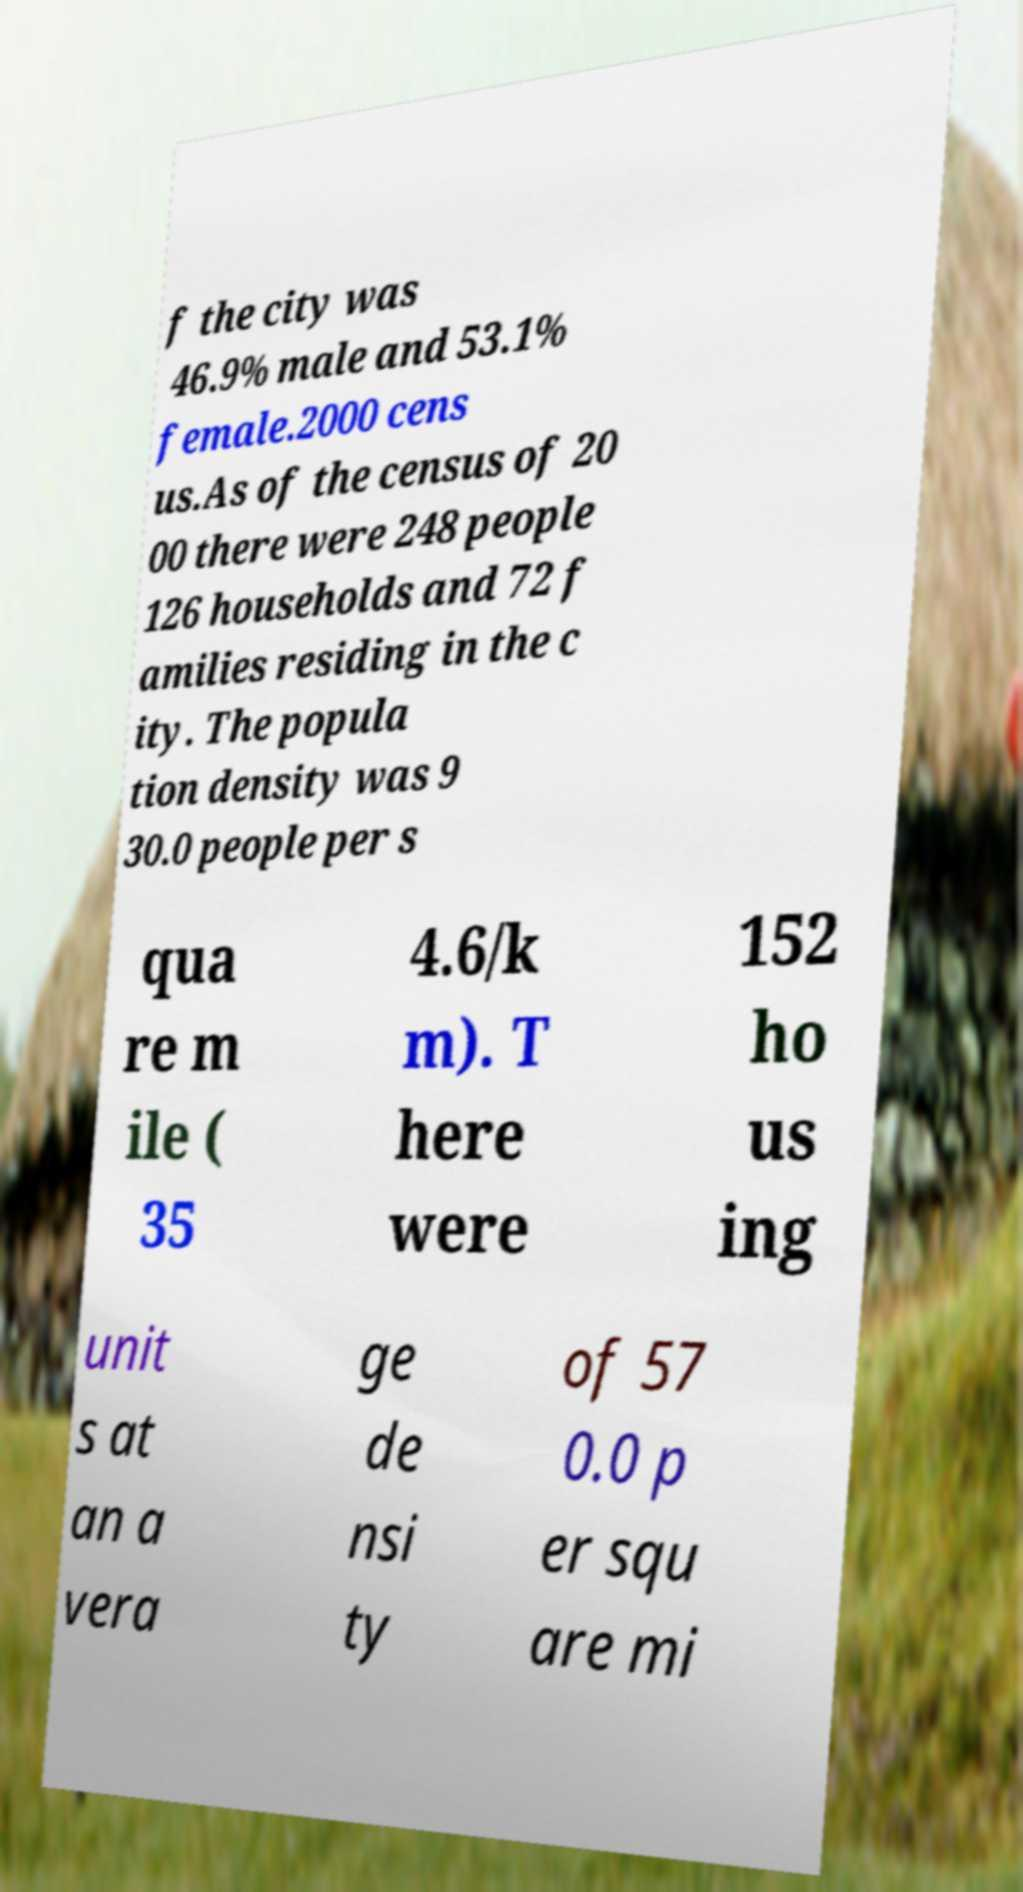Please identify and transcribe the text found in this image. f the city was 46.9% male and 53.1% female.2000 cens us.As of the census of 20 00 there were 248 people 126 households and 72 f amilies residing in the c ity. The popula tion density was 9 30.0 people per s qua re m ile ( 35 4.6/k m). T here were 152 ho us ing unit s at an a vera ge de nsi ty of 57 0.0 p er squ are mi 